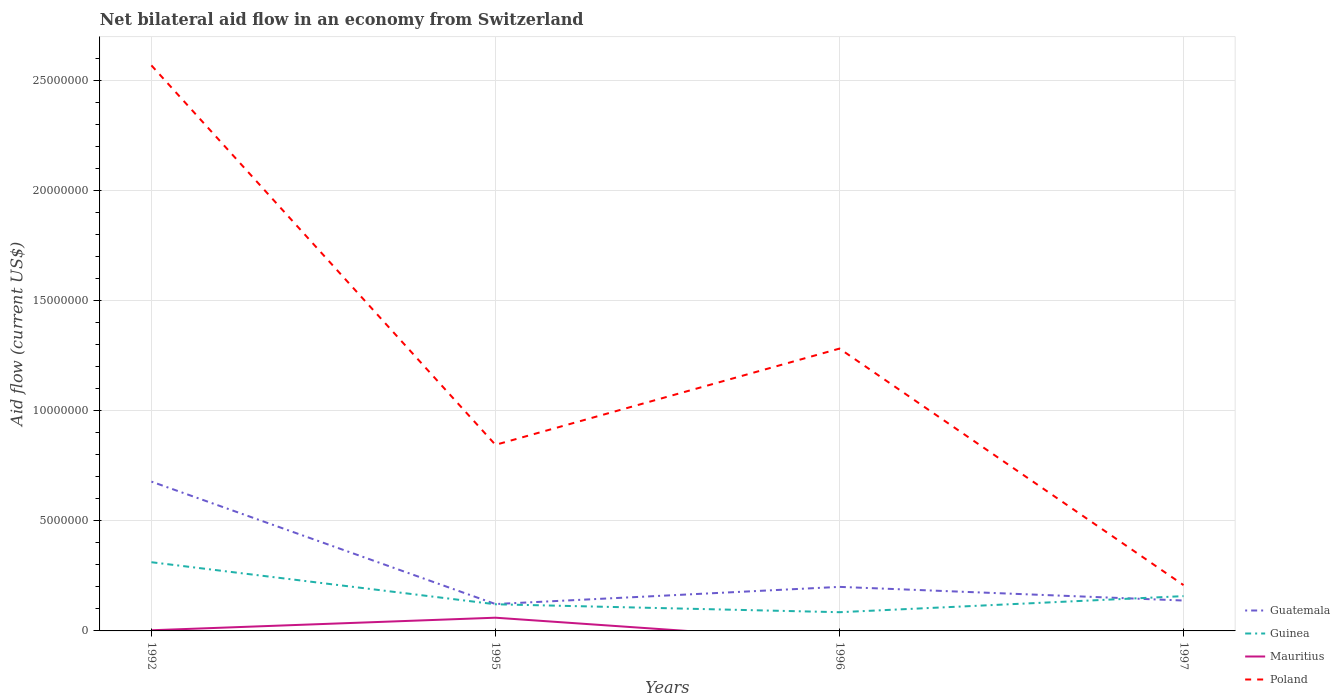Is the number of lines equal to the number of legend labels?
Provide a short and direct response. No. Across all years, what is the maximum net bilateral aid flow in Poland?
Your answer should be very brief. 2.08e+06. What is the total net bilateral aid flow in Guinea in the graph?
Ensure brevity in your answer.  2.27e+06. What is the difference between the highest and the second highest net bilateral aid flow in Guinea?
Make the answer very short. 2.27e+06. What is the difference between the highest and the lowest net bilateral aid flow in Mauritius?
Ensure brevity in your answer.  1. What is the difference between two consecutive major ticks on the Y-axis?
Make the answer very short. 5.00e+06. Does the graph contain any zero values?
Offer a very short reply. Yes. Does the graph contain grids?
Your answer should be compact. Yes. Where does the legend appear in the graph?
Your answer should be very brief. Bottom right. What is the title of the graph?
Your answer should be compact. Net bilateral aid flow in an economy from Switzerland. What is the label or title of the Y-axis?
Your response must be concise. Aid flow (current US$). What is the Aid flow (current US$) of Guatemala in 1992?
Your response must be concise. 6.78e+06. What is the Aid flow (current US$) in Guinea in 1992?
Provide a short and direct response. 3.12e+06. What is the Aid flow (current US$) in Poland in 1992?
Provide a succinct answer. 2.57e+07. What is the Aid flow (current US$) of Guatemala in 1995?
Offer a very short reply. 1.22e+06. What is the Aid flow (current US$) in Guinea in 1995?
Provide a short and direct response. 1.21e+06. What is the Aid flow (current US$) in Mauritius in 1995?
Your answer should be compact. 6.00e+05. What is the Aid flow (current US$) in Poland in 1995?
Provide a short and direct response. 8.45e+06. What is the Aid flow (current US$) in Guatemala in 1996?
Give a very brief answer. 2.00e+06. What is the Aid flow (current US$) of Guinea in 1996?
Offer a terse response. 8.50e+05. What is the Aid flow (current US$) in Poland in 1996?
Ensure brevity in your answer.  1.28e+07. What is the Aid flow (current US$) of Guatemala in 1997?
Give a very brief answer. 1.38e+06. What is the Aid flow (current US$) of Guinea in 1997?
Your response must be concise. 1.58e+06. What is the Aid flow (current US$) in Poland in 1997?
Keep it short and to the point. 2.08e+06. Across all years, what is the maximum Aid flow (current US$) of Guatemala?
Give a very brief answer. 6.78e+06. Across all years, what is the maximum Aid flow (current US$) in Guinea?
Your answer should be very brief. 3.12e+06. Across all years, what is the maximum Aid flow (current US$) in Mauritius?
Your response must be concise. 6.00e+05. Across all years, what is the maximum Aid flow (current US$) of Poland?
Keep it short and to the point. 2.57e+07. Across all years, what is the minimum Aid flow (current US$) of Guatemala?
Offer a terse response. 1.22e+06. Across all years, what is the minimum Aid flow (current US$) in Guinea?
Your answer should be very brief. 8.50e+05. Across all years, what is the minimum Aid flow (current US$) of Poland?
Make the answer very short. 2.08e+06. What is the total Aid flow (current US$) in Guatemala in the graph?
Your answer should be compact. 1.14e+07. What is the total Aid flow (current US$) of Guinea in the graph?
Your response must be concise. 6.76e+06. What is the total Aid flow (current US$) in Mauritius in the graph?
Ensure brevity in your answer.  6.30e+05. What is the total Aid flow (current US$) of Poland in the graph?
Provide a short and direct response. 4.90e+07. What is the difference between the Aid flow (current US$) of Guatemala in 1992 and that in 1995?
Ensure brevity in your answer.  5.56e+06. What is the difference between the Aid flow (current US$) in Guinea in 1992 and that in 1995?
Ensure brevity in your answer.  1.91e+06. What is the difference between the Aid flow (current US$) of Mauritius in 1992 and that in 1995?
Make the answer very short. -5.70e+05. What is the difference between the Aid flow (current US$) of Poland in 1992 and that in 1995?
Give a very brief answer. 1.72e+07. What is the difference between the Aid flow (current US$) of Guatemala in 1992 and that in 1996?
Make the answer very short. 4.78e+06. What is the difference between the Aid flow (current US$) of Guinea in 1992 and that in 1996?
Your answer should be compact. 2.27e+06. What is the difference between the Aid flow (current US$) of Poland in 1992 and that in 1996?
Offer a very short reply. 1.29e+07. What is the difference between the Aid flow (current US$) in Guatemala in 1992 and that in 1997?
Your answer should be very brief. 5.40e+06. What is the difference between the Aid flow (current US$) of Guinea in 1992 and that in 1997?
Ensure brevity in your answer.  1.54e+06. What is the difference between the Aid flow (current US$) of Poland in 1992 and that in 1997?
Give a very brief answer. 2.36e+07. What is the difference between the Aid flow (current US$) of Guatemala in 1995 and that in 1996?
Provide a short and direct response. -7.80e+05. What is the difference between the Aid flow (current US$) in Guinea in 1995 and that in 1996?
Your answer should be very brief. 3.60e+05. What is the difference between the Aid flow (current US$) of Poland in 1995 and that in 1996?
Make the answer very short. -4.37e+06. What is the difference between the Aid flow (current US$) of Guatemala in 1995 and that in 1997?
Offer a terse response. -1.60e+05. What is the difference between the Aid flow (current US$) of Guinea in 1995 and that in 1997?
Your answer should be compact. -3.70e+05. What is the difference between the Aid flow (current US$) of Poland in 1995 and that in 1997?
Your answer should be compact. 6.37e+06. What is the difference between the Aid flow (current US$) in Guatemala in 1996 and that in 1997?
Keep it short and to the point. 6.20e+05. What is the difference between the Aid flow (current US$) in Guinea in 1996 and that in 1997?
Ensure brevity in your answer.  -7.30e+05. What is the difference between the Aid flow (current US$) in Poland in 1996 and that in 1997?
Keep it short and to the point. 1.07e+07. What is the difference between the Aid flow (current US$) of Guatemala in 1992 and the Aid flow (current US$) of Guinea in 1995?
Keep it short and to the point. 5.57e+06. What is the difference between the Aid flow (current US$) of Guatemala in 1992 and the Aid flow (current US$) of Mauritius in 1995?
Give a very brief answer. 6.18e+06. What is the difference between the Aid flow (current US$) in Guatemala in 1992 and the Aid flow (current US$) in Poland in 1995?
Your answer should be very brief. -1.67e+06. What is the difference between the Aid flow (current US$) in Guinea in 1992 and the Aid flow (current US$) in Mauritius in 1995?
Provide a short and direct response. 2.52e+06. What is the difference between the Aid flow (current US$) in Guinea in 1992 and the Aid flow (current US$) in Poland in 1995?
Offer a terse response. -5.33e+06. What is the difference between the Aid flow (current US$) of Mauritius in 1992 and the Aid flow (current US$) of Poland in 1995?
Ensure brevity in your answer.  -8.42e+06. What is the difference between the Aid flow (current US$) of Guatemala in 1992 and the Aid flow (current US$) of Guinea in 1996?
Offer a very short reply. 5.93e+06. What is the difference between the Aid flow (current US$) of Guatemala in 1992 and the Aid flow (current US$) of Poland in 1996?
Offer a very short reply. -6.04e+06. What is the difference between the Aid flow (current US$) of Guinea in 1992 and the Aid flow (current US$) of Poland in 1996?
Give a very brief answer. -9.70e+06. What is the difference between the Aid flow (current US$) in Mauritius in 1992 and the Aid flow (current US$) in Poland in 1996?
Provide a short and direct response. -1.28e+07. What is the difference between the Aid flow (current US$) of Guatemala in 1992 and the Aid flow (current US$) of Guinea in 1997?
Offer a terse response. 5.20e+06. What is the difference between the Aid flow (current US$) of Guatemala in 1992 and the Aid flow (current US$) of Poland in 1997?
Your response must be concise. 4.70e+06. What is the difference between the Aid flow (current US$) in Guinea in 1992 and the Aid flow (current US$) in Poland in 1997?
Make the answer very short. 1.04e+06. What is the difference between the Aid flow (current US$) in Mauritius in 1992 and the Aid flow (current US$) in Poland in 1997?
Give a very brief answer. -2.05e+06. What is the difference between the Aid flow (current US$) in Guatemala in 1995 and the Aid flow (current US$) in Poland in 1996?
Give a very brief answer. -1.16e+07. What is the difference between the Aid flow (current US$) of Guinea in 1995 and the Aid flow (current US$) of Poland in 1996?
Ensure brevity in your answer.  -1.16e+07. What is the difference between the Aid flow (current US$) of Mauritius in 1995 and the Aid flow (current US$) of Poland in 1996?
Provide a succinct answer. -1.22e+07. What is the difference between the Aid flow (current US$) of Guatemala in 1995 and the Aid flow (current US$) of Guinea in 1997?
Ensure brevity in your answer.  -3.60e+05. What is the difference between the Aid flow (current US$) of Guatemala in 1995 and the Aid flow (current US$) of Poland in 1997?
Offer a terse response. -8.60e+05. What is the difference between the Aid flow (current US$) in Guinea in 1995 and the Aid flow (current US$) in Poland in 1997?
Provide a succinct answer. -8.70e+05. What is the difference between the Aid flow (current US$) of Mauritius in 1995 and the Aid flow (current US$) of Poland in 1997?
Your response must be concise. -1.48e+06. What is the difference between the Aid flow (current US$) of Guatemala in 1996 and the Aid flow (current US$) of Guinea in 1997?
Make the answer very short. 4.20e+05. What is the difference between the Aid flow (current US$) of Guinea in 1996 and the Aid flow (current US$) of Poland in 1997?
Provide a short and direct response. -1.23e+06. What is the average Aid flow (current US$) of Guatemala per year?
Offer a terse response. 2.84e+06. What is the average Aid flow (current US$) in Guinea per year?
Your answer should be very brief. 1.69e+06. What is the average Aid flow (current US$) of Mauritius per year?
Give a very brief answer. 1.58e+05. What is the average Aid flow (current US$) of Poland per year?
Ensure brevity in your answer.  1.23e+07. In the year 1992, what is the difference between the Aid flow (current US$) in Guatemala and Aid flow (current US$) in Guinea?
Give a very brief answer. 3.66e+06. In the year 1992, what is the difference between the Aid flow (current US$) of Guatemala and Aid flow (current US$) of Mauritius?
Your answer should be compact. 6.75e+06. In the year 1992, what is the difference between the Aid flow (current US$) in Guatemala and Aid flow (current US$) in Poland?
Make the answer very short. -1.89e+07. In the year 1992, what is the difference between the Aid flow (current US$) in Guinea and Aid flow (current US$) in Mauritius?
Make the answer very short. 3.09e+06. In the year 1992, what is the difference between the Aid flow (current US$) in Guinea and Aid flow (current US$) in Poland?
Give a very brief answer. -2.26e+07. In the year 1992, what is the difference between the Aid flow (current US$) in Mauritius and Aid flow (current US$) in Poland?
Your response must be concise. -2.56e+07. In the year 1995, what is the difference between the Aid flow (current US$) in Guatemala and Aid flow (current US$) in Guinea?
Your answer should be compact. 10000. In the year 1995, what is the difference between the Aid flow (current US$) of Guatemala and Aid flow (current US$) of Mauritius?
Your response must be concise. 6.20e+05. In the year 1995, what is the difference between the Aid flow (current US$) of Guatemala and Aid flow (current US$) of Poland?
Offer a very short reply. -7.23e+06. In the year 1995, what is the difference between the Aid flow (current US$) in Guinea and Aid flow (current US$) in Poland?
Your response must be concise. -7.24e+06. In the year 1995, what is the difference between the Aid flow (current US$) in Mauritius and Aid flow (current US$) in Poland?
Your answer should be compact. -7.85e+06. In the year 1996, what is the difference between the Aid flow (current US$) of Guatemala and Aid flow (current US$) of Guinea?
Keep it short and to the point. 1.15e+06. In the year 1996, what is the difference between the Aid flow (current US$) in Guatemala and Aid flow (current US$) in Poland?
Provide a short and direct response. -1.08e+07. In the year 1996, what is the difference between the Aid flow (current US$) of Guinea and Aid flow (current US$) of Poland?
Provide a short and direct response. -1.20e+07. In the year 1997, what is the difference between the Aid flow (current US$) of Guatemala and Aid flow (current US$) of Poland?
Make the answer very short. -7.00e+05. In the year 1997, what is the difference between the Aid flow (current US$) in Guinea and Aid flow (current US$) in Poland?
Provide a short and direct response. -5.00e+05. What is the ratio of the Aid flow (current US$) in Guatemala in 1992 to that in 1995?
Keep it short and to the point. 5.56. What is the ratio of the Aid flow (current US$) of Guinea in 1992 to that in 1995?
Give a very brief answer. 2.58. What is the ratio of the Aid flow (current US$) of Mauritius in 1992 to that in 1995?
Make the answer very short. 0.05. What is the ratio of the Aid flow (current US$) in Poland in 1992 to that in 1995?
Ensure brevity in your answer.  3.04. What is the ratio of the Aid flow (current US$) of Guatemala in 1992 to that in 1996?
Provide a short and direct response. 3.39. What is the ratio of the Aid flow (current US$) of Guinea in 1992 to that in 1996?
Provide a succinct answer. 3.67. What is the ratio of the Aid flow (current US$) of Poland in 1992 to that in 1996?
Keep it short and to the point. 2. What is the ratio of the Aid flow (current US$) in Guatemala in 1992 to that in 1997?
Give a very brief answer. 4.91. What is the ratio of the Aid flow (current US$) in Guinea in 1992 to that in 1997?
Ensure brevity in your answer.  1.97. What is the ratio of the Aid flow (current US$) of Poland in 1992 to that in 1997?
Make the answer very short. 12.35. What is the ratio of the Aid flow (current US$) of Guatemala in 1995 to that in 1996?
Offer a very short reply. 0.61. What is the ratio of the Aid flow (current US$) in Guinea in 1995 to that in 1996?
Provide a short and direct response. 1.42. What is the ratio of the Aid flow (current US$) in Poland in 1995 to that in 1996?
Ensure brevity in your answer.  0.66. What is the ratio of the Aid flow (current US$) of Guatemala in 1995 to that in 1997?
Your answer should be compact. 0.88. What is the ratio of the Aid flow (current US$) of Guinea in 1995 to that in 1997?
Offer a very short reply. 0.77. What is the ratio of the Aid flow (current US$) in Poland in 1995 to that in 1997?
Ensure brevity in your answer.  4.06. What is the ratio of the Aid flow (current US$) in Guatemala in 1996 to that in 1997?
Offer a very short reply. 1.45. What is the ratio of the Aid flow (current US$) of Guinea in 1996 to that in 1997?
Your response must be concise. 0.54. What is the ratio of the Aid flow (current US$) of Poland in 1996 to that in 1997?
Your answer should be compact. 6.16. What is the difference between the highest and the second highest Aid flow (current US$) of Guatemala?
Give a very brief answer. 4.78e+06. What is the difference between the highest and the second highest Aid flow (current US$) in Guinea?
Your answer should be very brief. 1.54e+06. What is the difference between the highest and the second highest Aid flow (current US$) of Poland?
Provide a succinct answer. 1.29e+07. What is the difference between the highest and the lowest Aid flow (current US$) in Guatemala?
Your answer should be very brief. 5.56e+06. What is the difference between the highest and the lowest Aid flow (current US$) of Guinea?
Make the answer very short. 2.27e+06. What is the difference between the highest and the lowest Aid flow (current US$) of Mauritius?
Make the answer very short. 6.00e+05. What is the difference between the highest and the lowest Aid flow (current US$) of Poland?
Offer a terse response. 2.36e+07. 